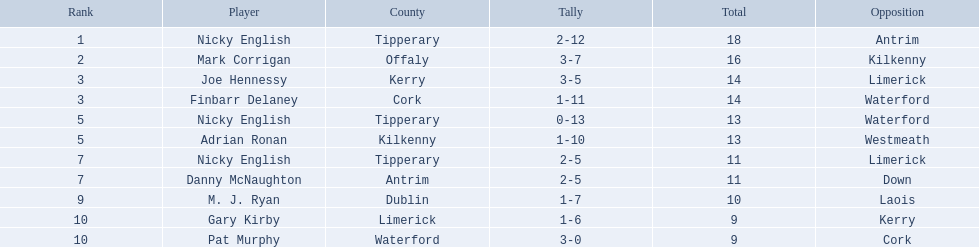What numbers are in the total column? 18, 16, 14, 14, 13, 13, 11, 11, 10, 9, 9. What row has the number 10 in the total column? 9, M. J. Ryan, Dublin, 1-7, 10, Laois. What name is in the player column for this row? M. J. Ryan. Write the full table. {'header': ['Rank', 'Player', 'County', 'Tally', 'Total', 'Opposition'], 'rows': [['1', 'Nicky English', 'Tipperary', '2-12', '18', 'Antrim'], ['2', 'Mark Corrigan', 'Offaly', '3-7', '16', 'Kilkenny'], ['3', 'Joe Hennessy', 'Kerry', '3-5', '14', 'Limerick'], ['3', 'Finbarr Delaney', 'Cork', '1-11', '14', 'Waterford'], ['5', 'Nicky English', 'Tipperary', '0-13', '13', 'Waterford'], ['5', 'Adrian Ronan', 'Kilkenny', '1-10', '13', 'Westmeath'], ['7', 'Nicky English', 'Tipperary', '2-5', '11', 'Limerick'], ['7', 'Danny McNaughton', 'Antrim', '2-5', '11', 'Down'], ['9', 'M. J. Ryan', 'Dublin', '1-7', '10', 'Laois'], ['10', 'Gary Kirby', 'Limerick', '1-6', '9', 'Kerry'], ['10', 'Pat Murphy', 'Waterford', '3-0', '9', 'Cork']]} Who are all the players? Nicky English, Mark Corrigan, Joe Hennessy, Finbarr Delaney, Nicky English, Adrian Ronan, Nicky English, Danny McNaughton, M. J. Ryan, Gary Kirby, Pat Murphy. How many points did they receive? 18, 16, 14, 14, 13, 13, 11, 11, 10, 9, 9. And which player received 10 points? M. J. Ryan. Who are the involved players? Nicky English, Mark Corrigan, Joe Hennessy, Finbarr Delaney, Nicky English, Adrian Ronan, Nicky English, Danny McNaughton, M. J. Ryan, Gary Kirby, Pat Murphy. What is the count of points each one gained? 18, 16, 14, 14, 13, 13, 11, 11, 10, 9, 9. And which one of them obtained 10 points? M. J. Ryan. 